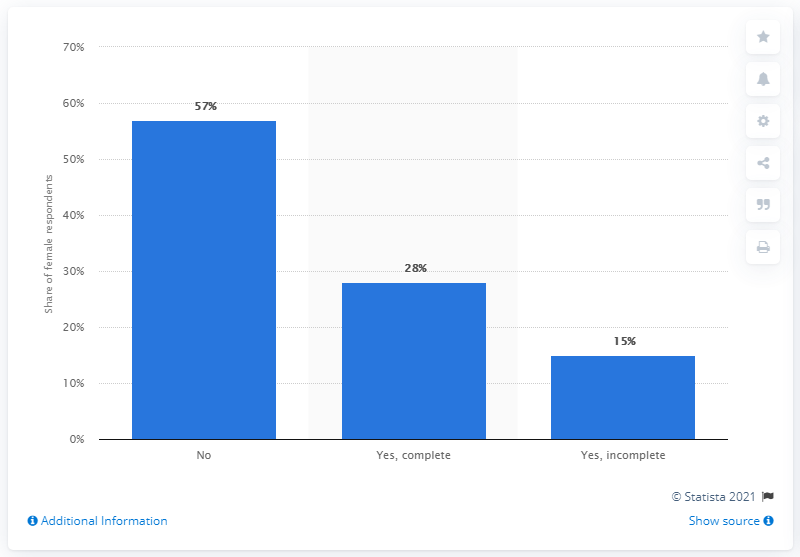Give some essential details in this illustration. According to 15% of the girls surveyed, they have had a complete sexual experience. 